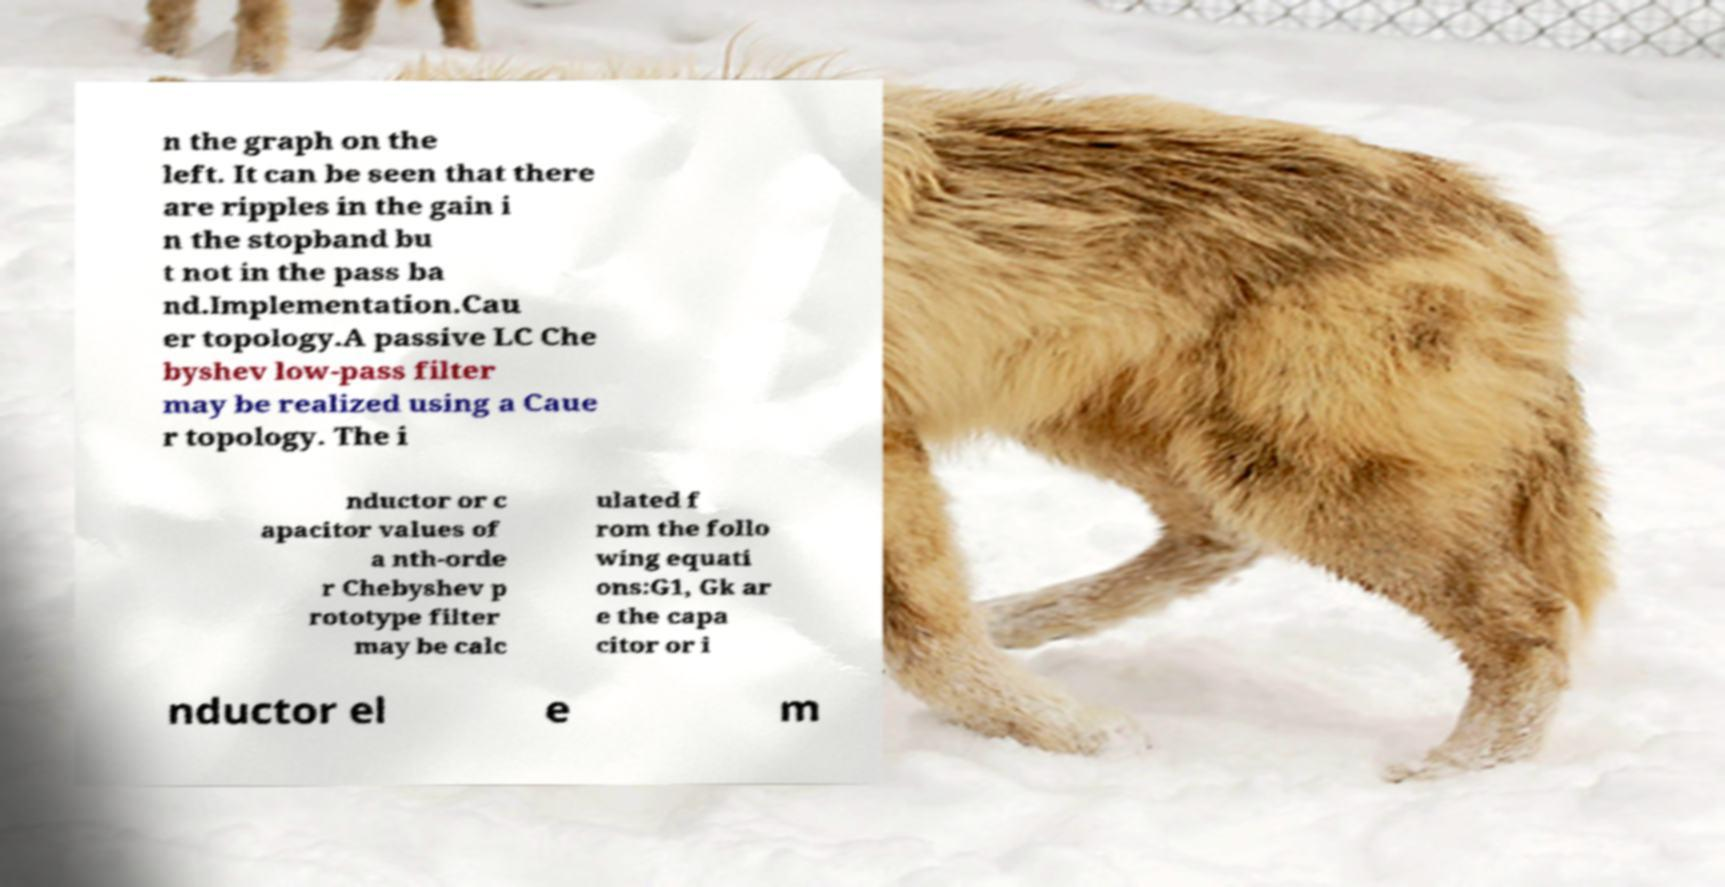I need the written content from this picture converted into text. Can you do that? n the graph on the left. It can be seen that there are ripples in the gain i n the stopband bu t not in the pass ba nd.Implementation.Cau er topology.A passive LC Che byshev low-pass filter may be realized using a Caue r topology. The i nductor or c apacitor values of a nth-orde r Chebyshev p rototype filter may be calc ulated f rom the follo wing equati ons:G1, Gk ar e the capa citor or i nductor el e m 